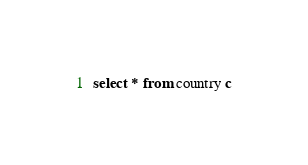<code> <loc_0><loc_0><loc_500><loc_500><_SQL_>select * from country c
</code> 